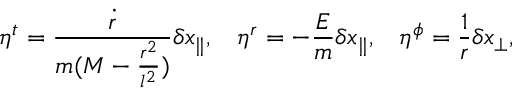<formula> <loc_0><loc_0><loc_500><loc_500>\eta ^ { t } = \frac { \dot { r } } { m ( M - \frac { r ^ { 2 } } { l ^ { 2 } } ) } \delta x _ { \| } , \, \eta ^ { r } = - \frac { E } { m } \delta x _ { \| } , \, \eta ^ { \phi } = \frac { 1 } { r } \delta x _ { \perp } ,</formula> 